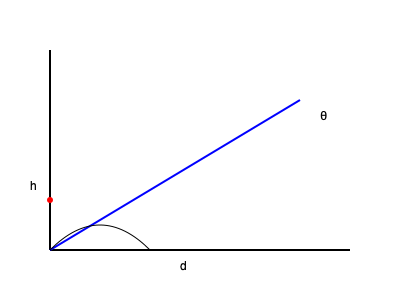As a volleyball player like Paige Sander, you're practicing your spike technique. If you're standing 8 meters from the net and your hitting point is 3 meters above the ground, what is the optimal angle θ (in degrees) for your spike to clear the net, which is 2.43 meters high? To solve this problem, we'll follow these steps:

1) First, let's identify the variables:
   h = height of hitting point - height of net = 3m - 2.43m = 0.57m
   d = distance from net = 8m

2) The optimal angle for the spike is the one that just clears the net. This creates a right triangle where:
   - The base is the distance to the net (d)
   - The height is the difference between the hitting point and net height (h)
   - The hypotenuse is the path of the ball

3) We can find the angle using the arctangent function:

   $$θ = \arctan(\frac{h}{d})$$

4) Plugging in our values:

   $$θ = \arctan(\frac{0.57}{8})$$

5) Calculate:
   $$θ = \arctan(0.07125) ≈ 0.0712 \text{ radians}$$

6) Convert to degrees:
   $$θ ≈ 0.0712 \times \frac{180°}{\pi} ≈ 4.08°$$

Therefore, the optimal angle for the spike is approximately 4.08 degrees.
Answer: 4.08° 